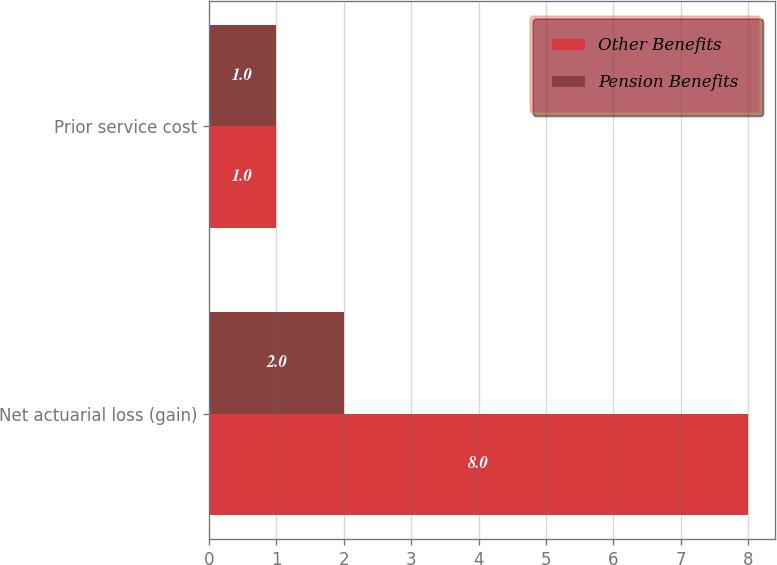Convert chart to OTSL. <chart><loc_0><loc_0><loc_500><loc_500><stacked_bar_chart><ecel><fcel>Net actuarial loss (gain)<fcel>Prior service cost<nl><fcel>Other Benefits<fcel>8<fcel>1<nl><fcel>Pension Benefits<fcel>2<fcel>1<nl></chart> 